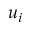<formula> <loc_0><loc_0><loc_500><loc_500>u _ { i }</formula> 